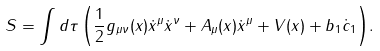Convert formula to latex. <formula><loc_0><loc_0><loc_500><loc_500>S = \int { d \tau \left ( \frac { 1 } { 2 } g _ { \mu \nu } ( x ) \dot { x } ^ { \mu } \dot { x } ^ { \nu } + A _ { \mu } ( x ) \dot { x } ^ { \mu } + V ( x ) + b _ { 1 } \dot { c } _ { 1 } \right ) } .</formula> 